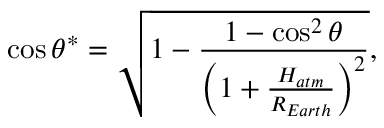<formula> <loc_0><loc_0><loc_500><loc_500>\cos \theta ^ { * } = \sqrt { 1 - \frac { 1 - \cos ^ { 2 } \theta } { \left ( 1 + \frac { H _ { a t m } } { R _ { E a r t h } } \right ) ^ { 2 } } } ,</formula> 